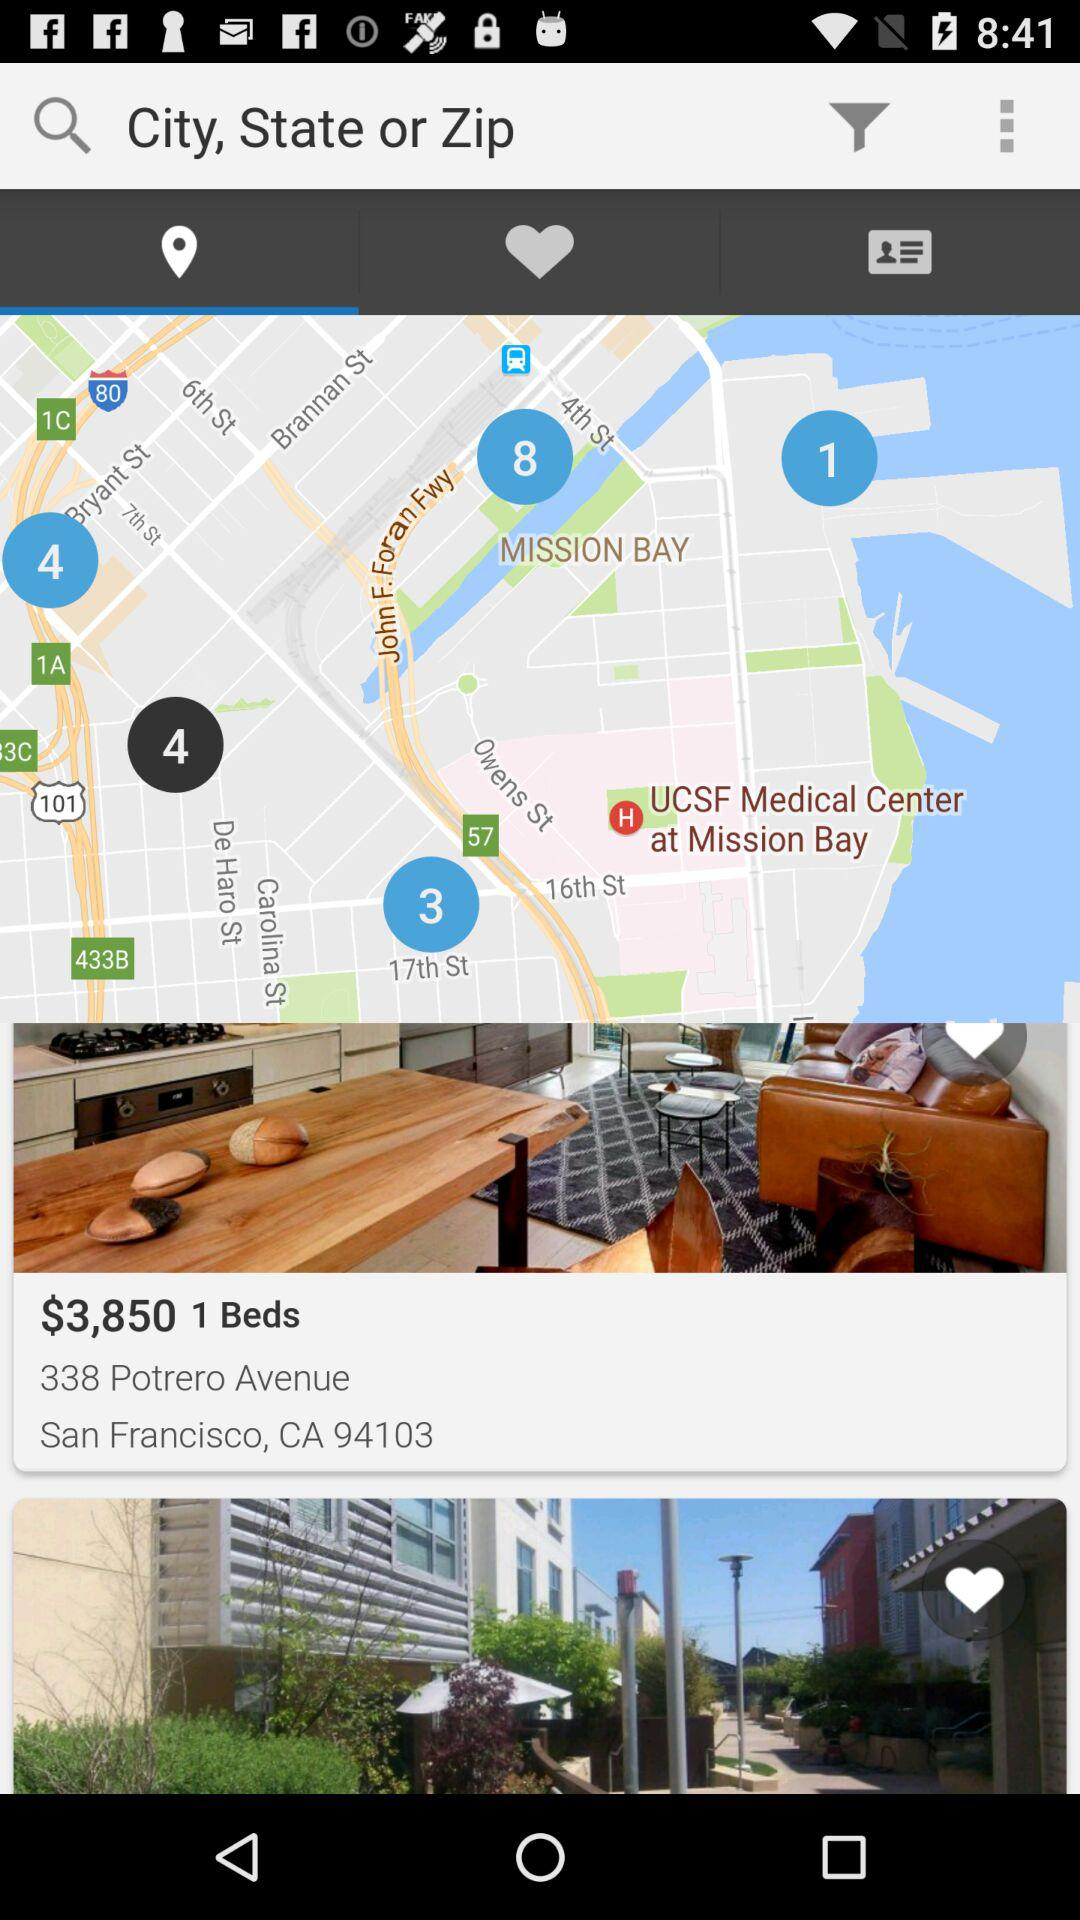What is the address of 338 Portero Avenue? The address is San Francisco, CA 94103. 